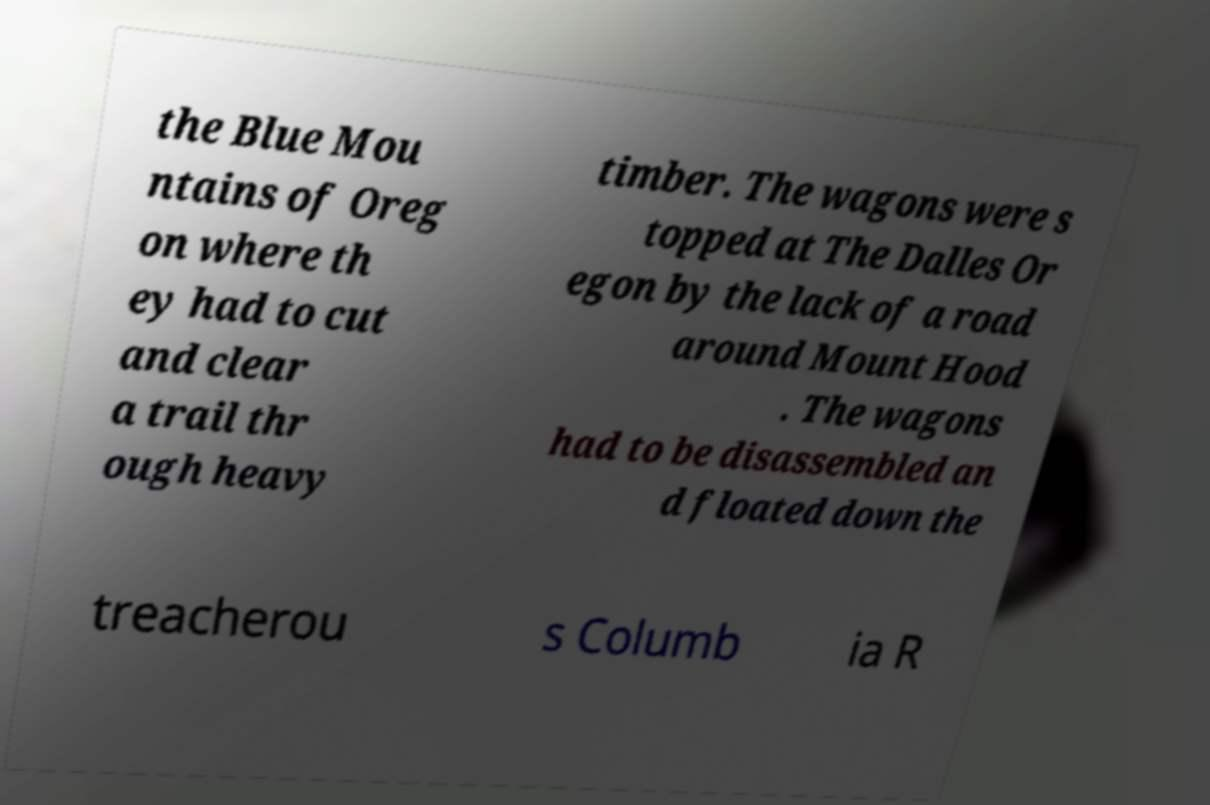What messages or text are displayed in this image? I need them in a readable, typed format. the Blue Mou ntains of Oreg on where th ey had to cut and clear a trail thr ough heavy timber. The wagons were s topped at The Dalles Or egon by the lack of a road around Mount Hood . The wagons had to be disassembled an d floated down the treacherou s Columb ia R 